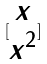Convert formula to latex. <formula><loc_0><loc_0><loc_500><loc_500>[ \begin{matrix} x \\ x ^ { 2 } \end{matrix} ]</formula> 